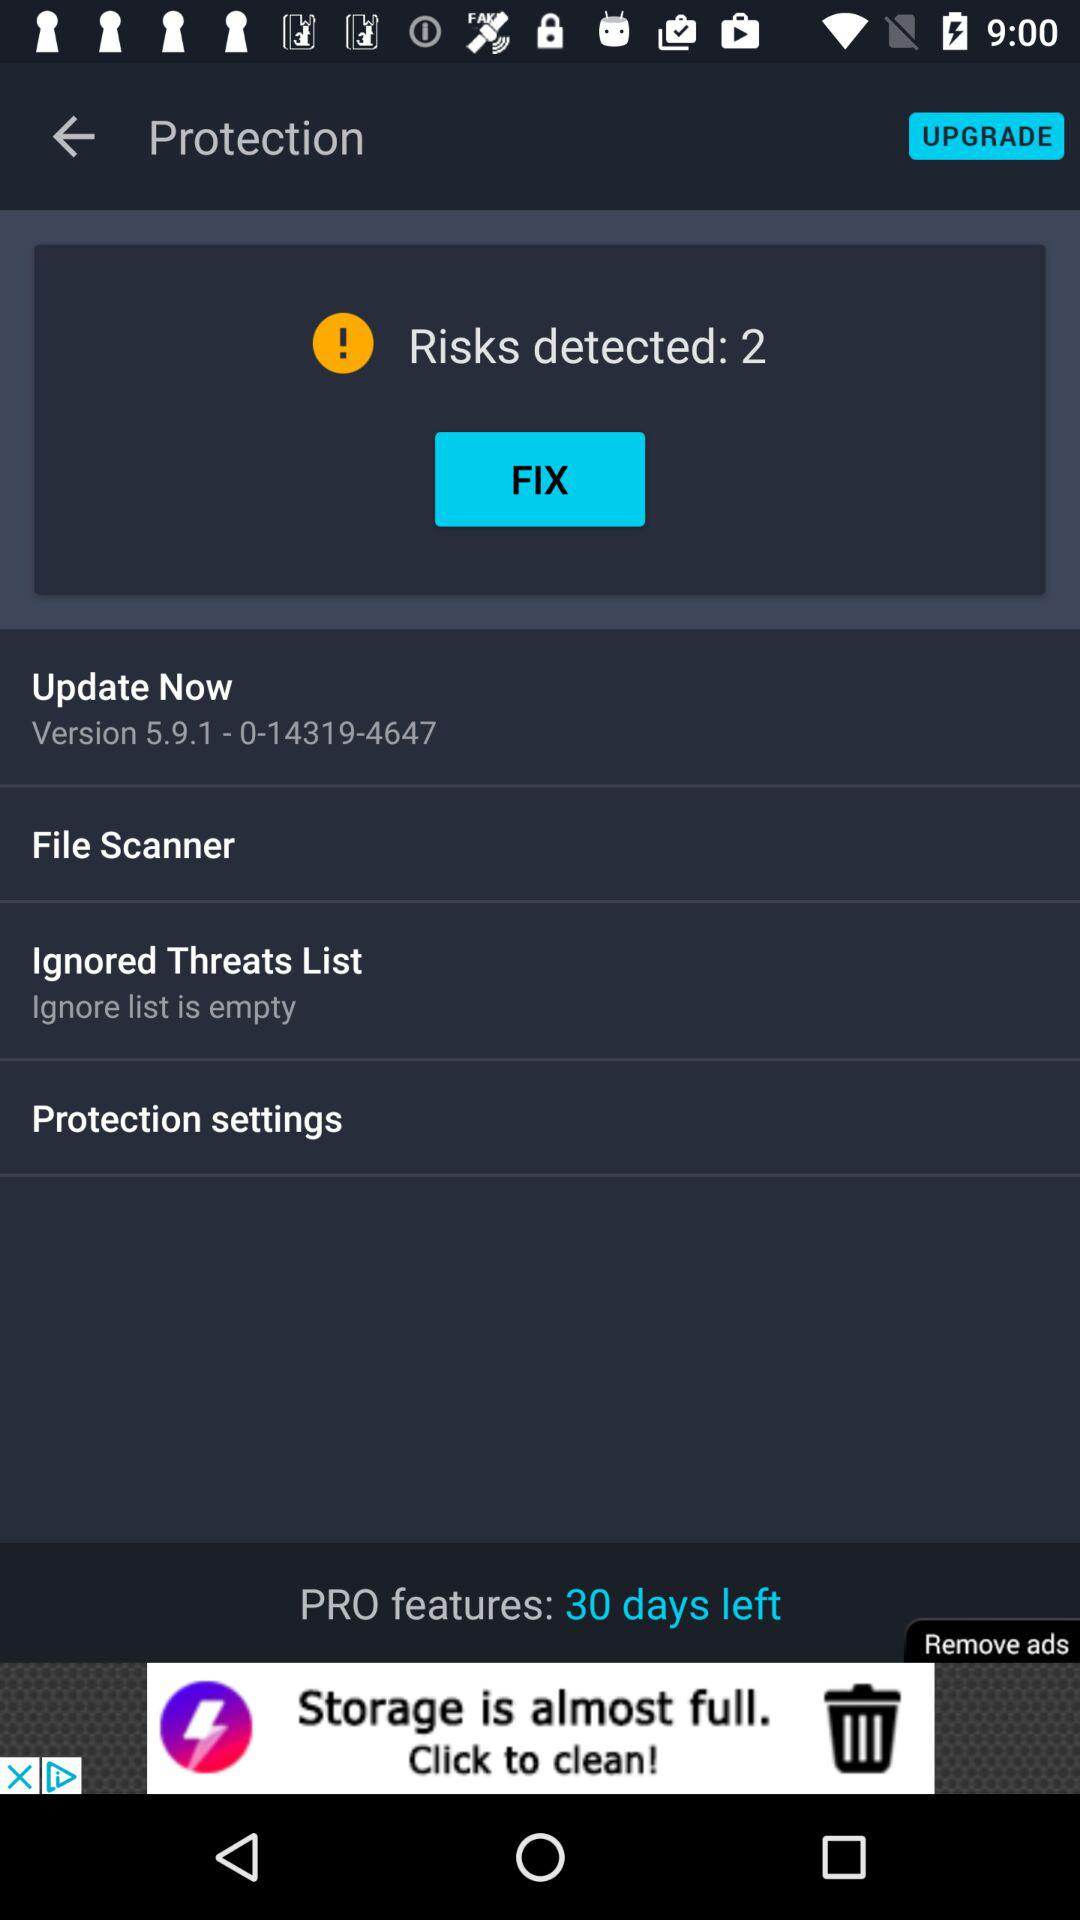How many days are left for pro features? There are 30 days left for pro features. 